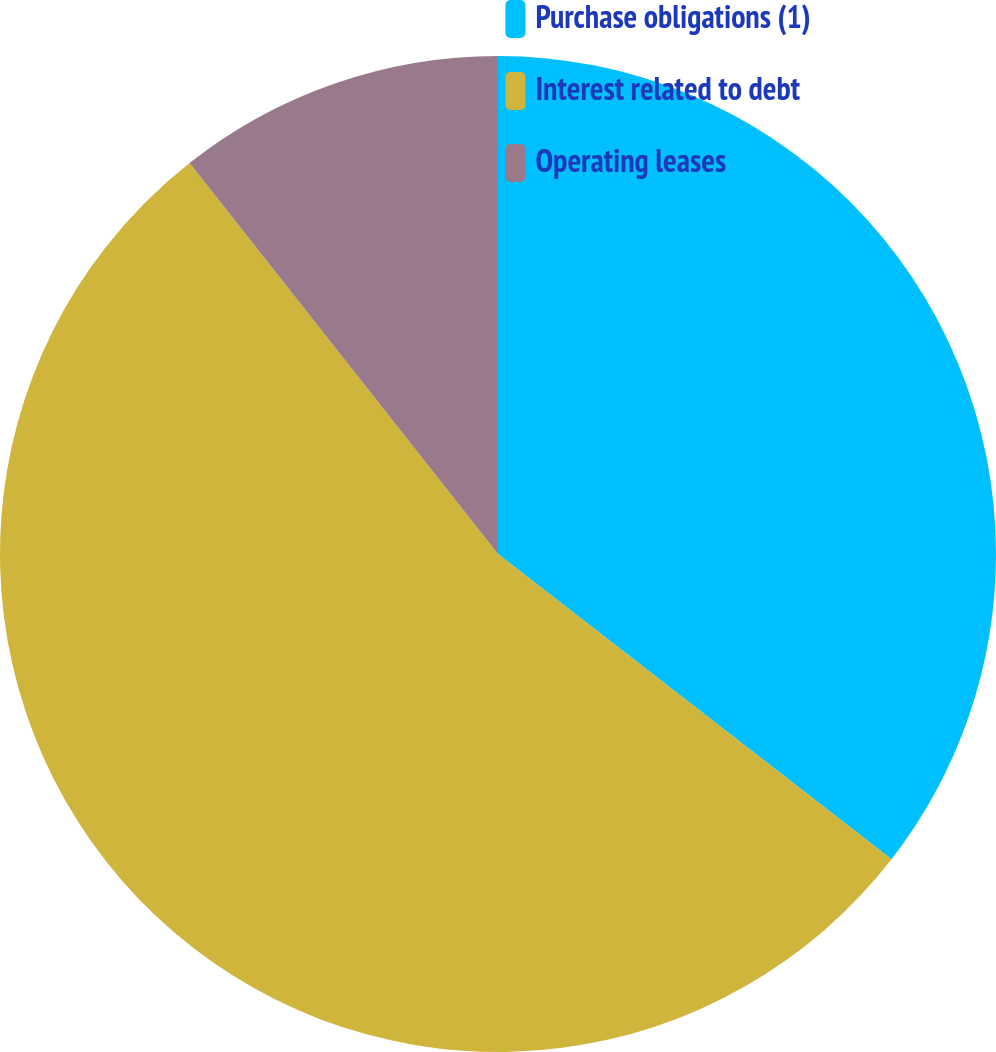Convert chart to OTSL. <chart><loc_0><loc_0><loc_500><loc_500><pie_chart><fcel>Purchase obligations (1)<fcel>Interest related to debt<fcel>Operating leases<nl><fcel>35.5%<fcel>53.87%<fcel>10.63%<nl></chart> 